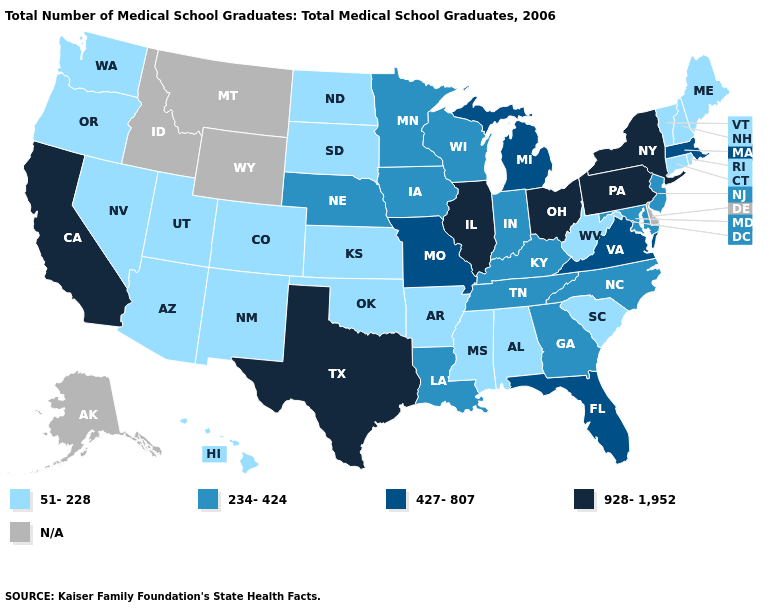Does Texas have the highest value in the South?
Concise answer only. Yes. What is the value of Idaho?
Concise answer only. N/A. What is the value of Kansas?
Write a very short answer. 51-228. Name the states that have a value in the range N/A?
Quick response, please. Alaska, Delaware, Idaho, Montana, Wyoming. What is the value of Florida?
Give a very brief answer. 427-807. What is the value of Idaho?
Keep it brief. N/A. Does the map have missing data?
Give a very brief answer. Yes. What is the value of Alaska?
Quick response, please. N/A. What is the value of South Carolina?
Be succinct. 51-228. What is the value of Louisiana?
Answer briefly. 234-424. Name the states that have a value in the range 928-1,952?
Give a very brief answer. California, Illinois, New York, Ohio, Pennsylvania, Texas. What is the value of Florida?
Short answer required. 427-807. What is the highest value in the USA?
Concise answer only. 928-1,952. Name the states that have a value in the range 234-424?
Give a very brief answer. Georgia, Indiana, Iowa, Kentucky, Louisiana, Maryland, Minnesota, Nebraska, New Jersey, North Carolina, Tennessee, Wisconsin. Among the states that border Washington , which have the highest value?
Short answer required. Oregon. 